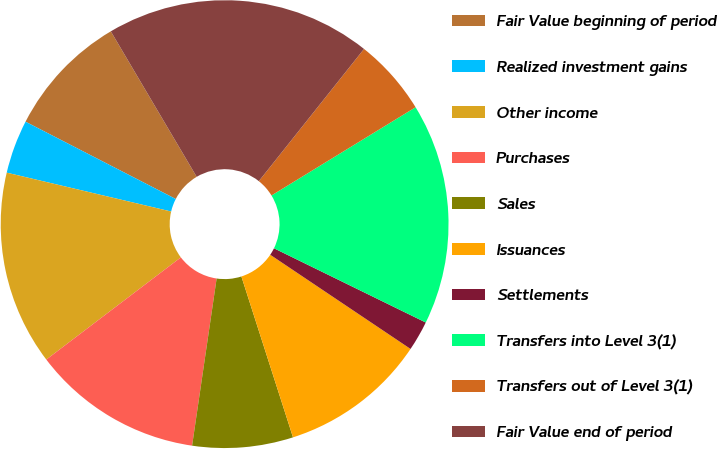Convert chart. <chart><loc_0><loc_0><loc_500><loc_500><pie_chart><fcel>Fair Value beginning of period<fcel>Realized investment gains<fcel>Other income<fcel>Purchases<fcel>Sales<fcel>Issuances<fcel>Settlements<fcel>Transfers into Level 3(1)<fcel>Transfers out of Level 3(1)<fcel>Fair Value end of period<nl><fcel>8.95%<fcel>3.87%<fcel>14.03%<fcel>12.34%<fcel>7.26%<fcel>10.65%<fcel>2.17%<fcel>15.98%<fcel>5.56%<fcel>19.18%<nl></chart> 